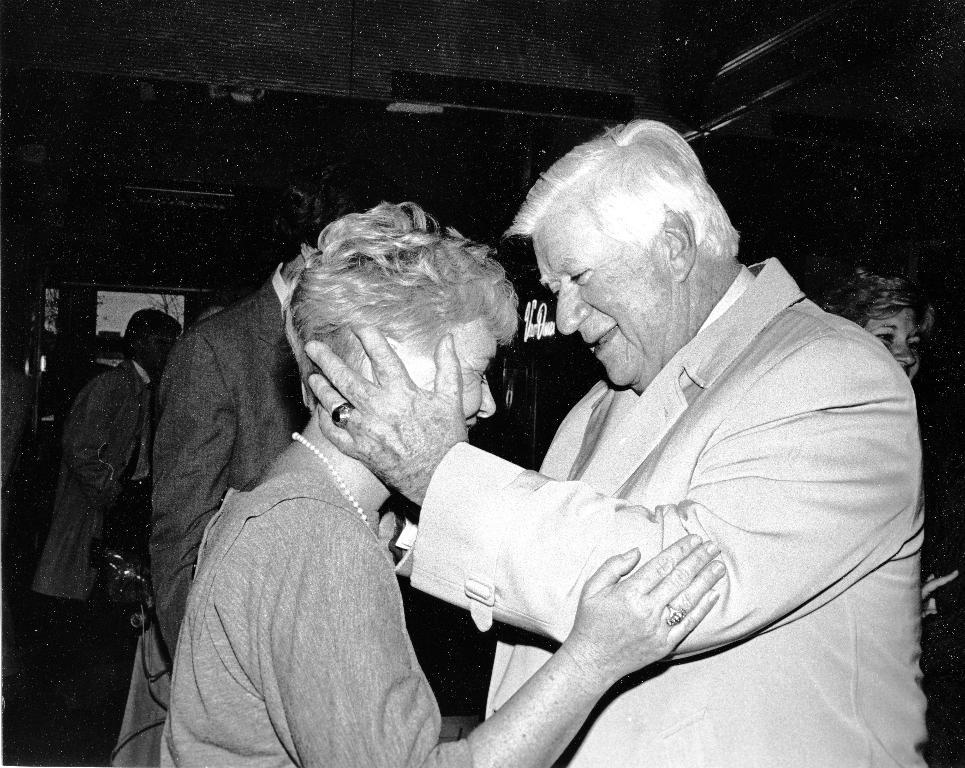Who is the main subject in the image? There is a man in the image. What is the man doing in the image? The man is holding a woman. Can you describe the background of the image? There are people and trees visible in the background of the image. What type of wood is the man using to build a pipe in the image? There is no wood or pipe present in the image; the man is holding a woman. 